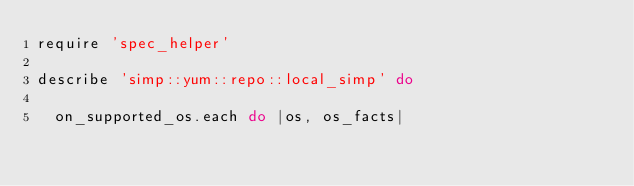Convert code to text. <code><loc_0><loc_0><loc_500><loc_500><_Ruby_>require 'spec_helper'

describe 'simp::yum::repo::local_simp' do

  on_supported_os.each do |os, os_facts|</code> 